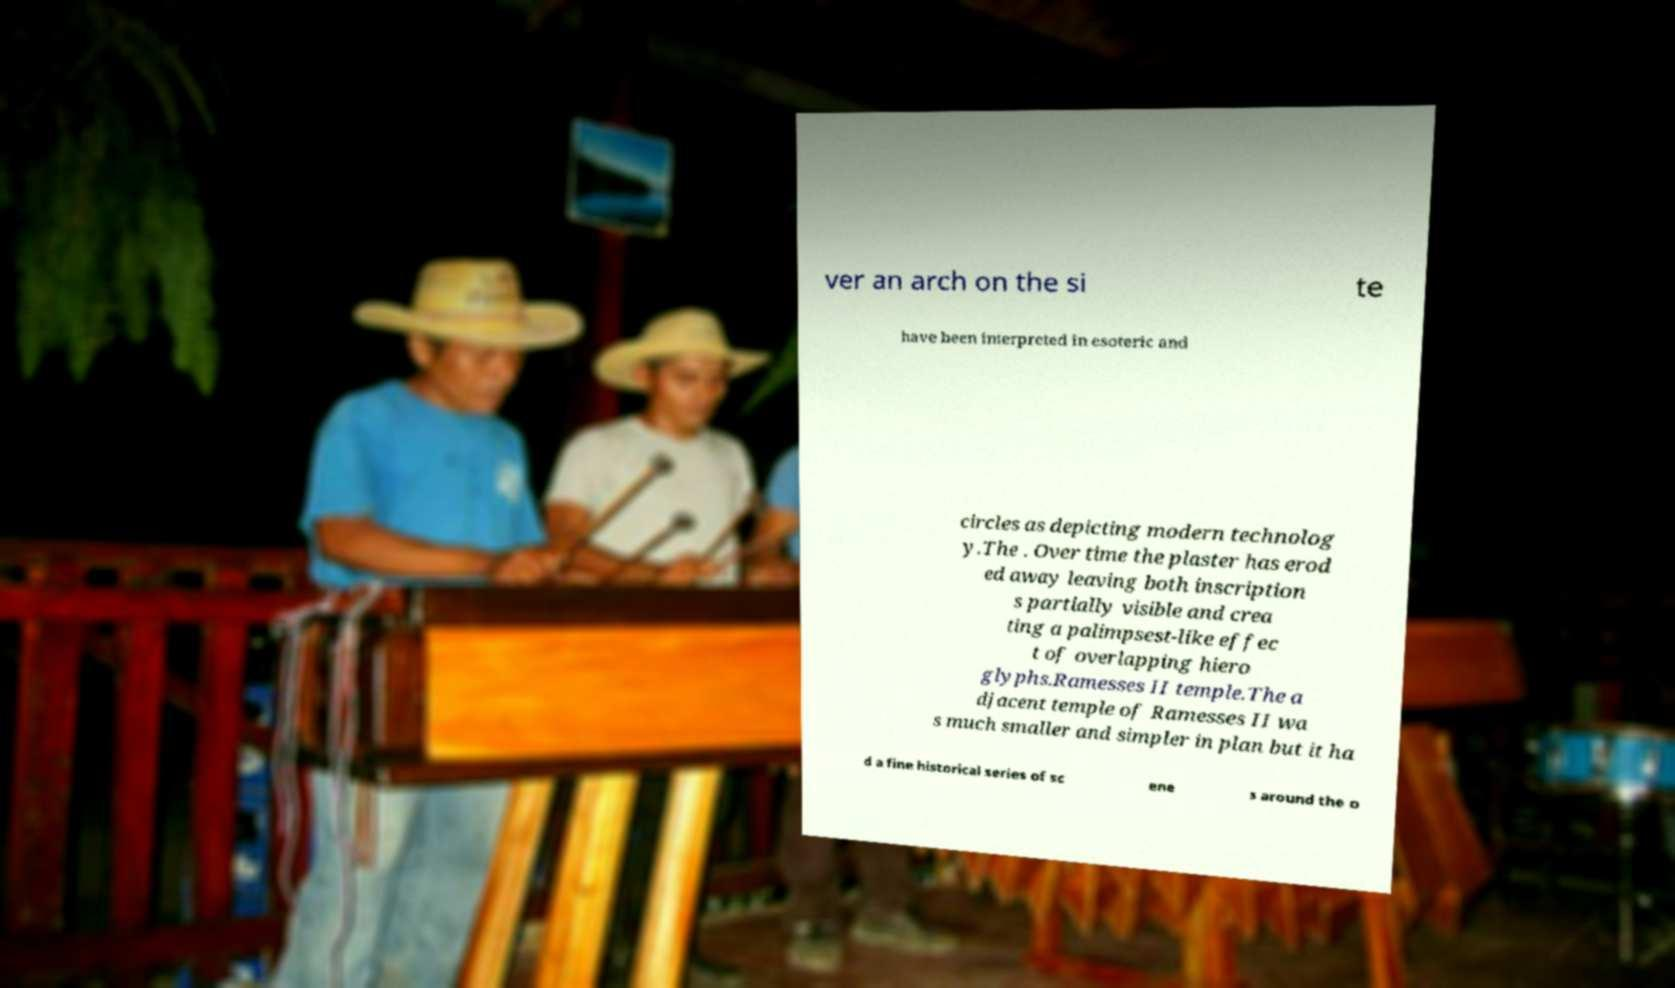Please identify and transcribe the text found in this image. ver an arch on the si te have been interpreted in esoteric and circles as depicting modern technolog y.The . Over time the plaster has erod ed away leaving both inscription s partially visible and crea ting a palimpsest-like effec t of overlapping hiero glyphs.Ramesses II temple.The a djacent temple of Ramesses II wa s much smaller and simpler in plan but it ha d a fine historical series of sc ene s around the o 